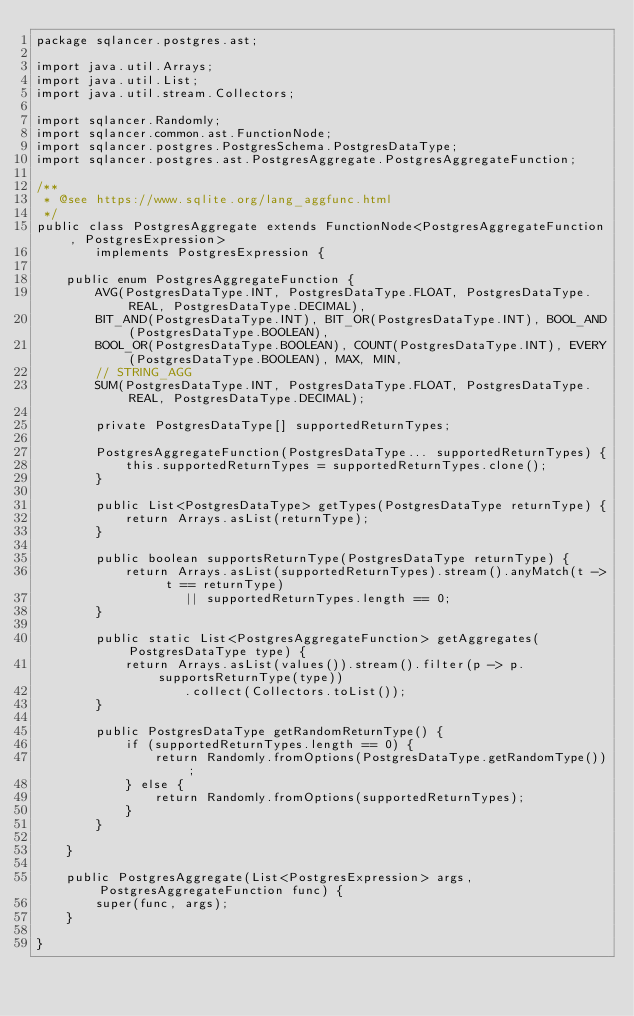Convert code to text. <code><loc_0><loc_0><loc_500><loc_500><_Java_>package sqlancer.postgres.ast;

import java.util.Arrays;
import java.util.List;
import java.util.stream.Collectors;

import sqlancer.Randomly;
import sqlancer.common.ast.FunctionNode;
import sqlancer.postgres.PostgresSchema.PostgresDataType;
import sqlancer.postgres.ast.PostgresAggregate.PostgresAggregateFunction;

/**
 * @see https://www.sqlite.org/lang_aggfunc.html
 */
public class PostgresAggregate extends FunctionNode<PostgresAggregateFunction, PostgresExpression>
        implements PostgresExpression {

    public enum PostgresAggregateFunction {
        AVG(PostgresDataType.INT, PostgresDataType.FLOAT, PostgresDataType.REAL, PostgresDataType.DECIMAL),
        BIT_AND(PostgresDataType.INT), BIT_OR(PostgresDataType.INT), BOOL_AND(PostgresDataType.BOOLEAN),
        BOOL_OR(PostgresDataType.BOOLEAN), COUNT(PostgresDataType.INT), EVERY(PostgresDataType.BOOLEAN), MAX, MIN,
        // STRING_AGG
        SUM(PostgresDataType.INT, PostgresDataType.FLOAT, PostgresDataType.REAL, PostgresDataType.DECIMAL);

        private PostgresDataType[] supportedReturnTypes;

        PostgresAggregateFunction(PostgresDataType... supportedReturnTypes) {
            this.supportedReturnTypes = supportedReturnTypes.clone();
        }

        public List<PostgresDataType> getTypes(PostgresDataType returnType) {
            return Arrays.asList(returnType);
        }

        public boolean supportsReturnType(PostgresDataType returnType) {
            return Arrays.asList(supportedReturnTypes).stream().anyMatch(t -> t == returnType)
                    || supportedReturnTypes.length == 0;
        }

        public static List<PostgresAggregateFunction> getAggregates(PostgresDataType type) {
            return Arrays.asList(values()).stream().filter(p -> p.supportsReturnType(type))
                    .collect(Collectors.toList());
        }

        public PostgresDataType getRandomReturnType() {
            if (supportedReturnTypes.length == 0) {
                return Randomly.fromOptions(PostgresDataType.getRandomType());
            } else {
                return Randomly.fromOptions(supportedReturnTypes);
            }
        }

    }

    public PostgresAggregate(List<PostgresExpression> args, PostgresAggregateFunction func) {
        super(func, args);
    }

}
</code> 